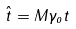<formula> <loc_0><loc_0><loc_500><loc_500>\hat { t } = M \gamma _ { o } t</formula> 